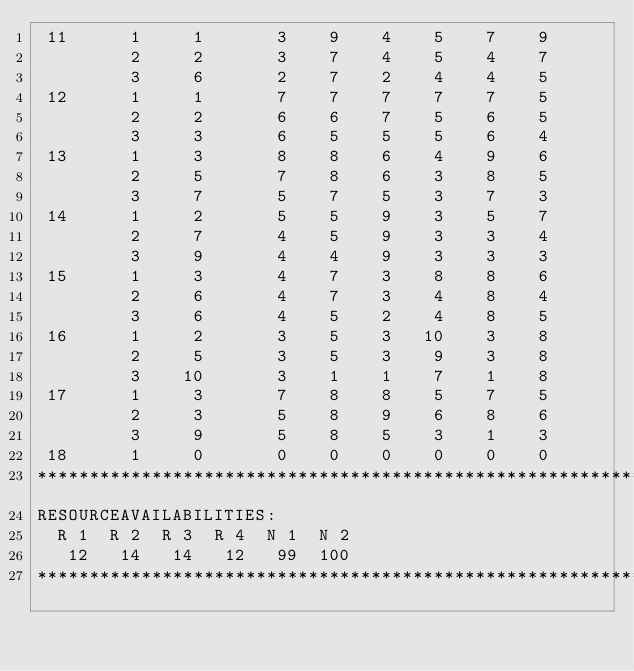<code> <loc_0><loc_0><loc_500><loc_500><_ObjectiveC_> 11      1     1       3    9    4    5    7    9
         2     2       3    7    4    5    4    7
         3     6       2    7    2    4    4    5
 12      1     1       7    7    7    7    7    5
         2     2       6    6    7    5    6    5
         3     3       6    5    5    5    6    4
 13      1     3       8    8    6    4    9    6
         2     5       7    8    6    3    8    5
         3     7       5    7    5    3    7    3
 14      1     2       5    5    9    3    5    7
         2     7       4    5    9    3    3    4
         3     9       4    4    9    3    3    3
 15      1     3       4    7    3    8    8    6
         2     6       4    7    3    4    8    4
         3     6       4    5    2    4    8    5
 16      1     2       3    5    3   10    3    8
         2     5       3    5    3    9    3    8
         3    10       3    1    1    7    1    8
 17      1     3       7    8    8    5    7    5
         2     3       5    8    9    6    8    6
         3     9       5    8    5    3    1    3
 18      1     0       0    0    0    0    0    0
************************************************************************
RESOURCEAVAILABILITIES:
  R 1  R 2  R 3  R 4  N 1  N 2
   12   14   14   12   99  100
************************************************************************
</code> 